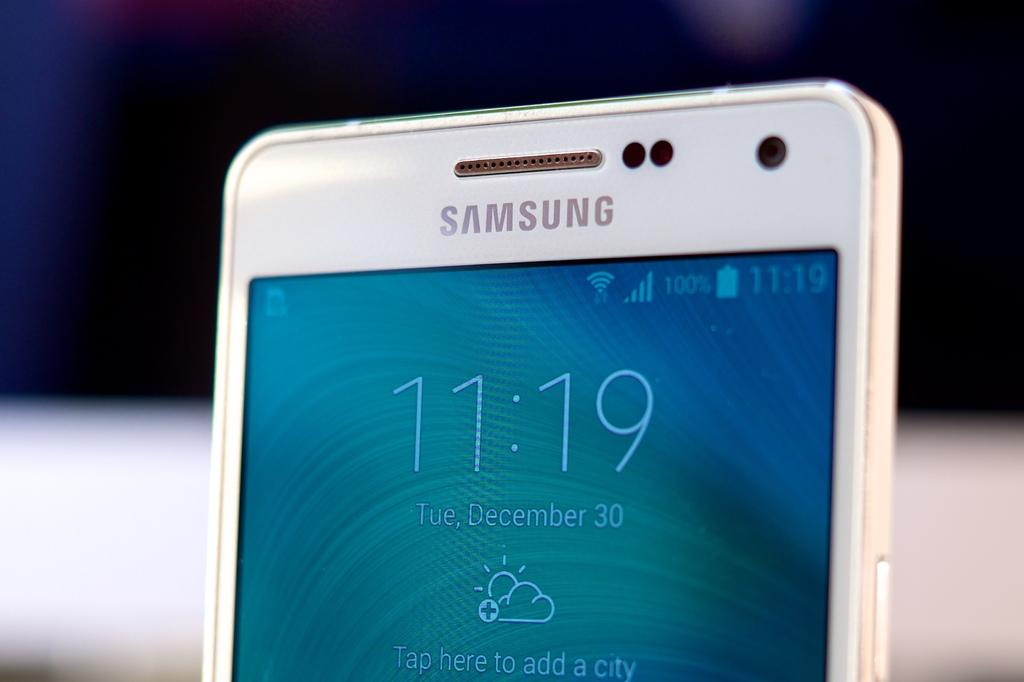Provide a one-sentence caption for the provided image. A white Samsung smartphone shows the time is 11:19. 